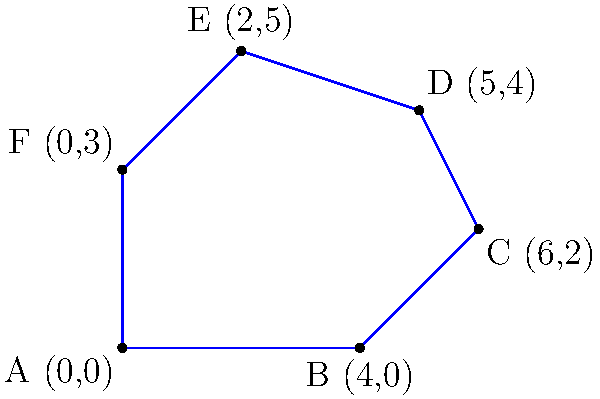As a product owner, you're visualizing project phases as an irregular polygon. Each side represents a phase duration in weeks. Calculate the project's total duration (perimeter) given the coordinates of the polygon's vertices: A(0,0), B(4,0), C(6,2), D(5,4), E(2,5), and F(0,3). To calculate the perimeter, we need to find the length of each side and sum them up:

1. Side AB: $\sqrt{(4-0)^2 + (0-0)^2} = 4$
2. Side BC: $\sqrt{(6-4)^2 + (2-0)^2} = \sqrt{8} = 2\sqrt{2}$
3. Side CD: $\sqrt{(5-6)^2 + (4-2)^2} = \sqrt{5}$
4. Side DE: $\sqrt{(2-5)^2 + (5-4)^2} = \sqrt{10}$
5. Side EF: $\sqrt{(0-2)^2 + (3-5)^2} = \sqrt{8} = 2\sqrt{2}$
6. Side FA: $\sqrt{(0-0)^2 + (0-3)^2} = 3$

Sum of all sides:
$$4 + 2\sqrt{2} + \sqrt{5} + \sqrt{10} + 2\sqrt{2} + 3$$

Simplifying:
$$7 + 4\sqrt{2} + \sqrt{5} + \sqrt{10}$$

This represents the total project duration in weeks.
Answer: $7 + 4\sqrt{2} + \sqrt{5} + \sqrt{10}$ weeks 